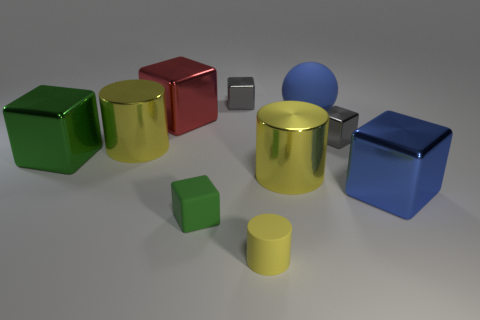Is the number of yellow matte cylinders left of the red metallic thing the same as the number of large metallic cylinders?
Offer a terse response. No. What color is the matte object that is the same shape as the red metal thing?
Your answer should be very brief. Green. How many metallic things have the same shape as the small yellow matte thing?
Offer a very short reply. 2. There is another big cube that is the same color as the matte block; what is it made of?
Your response must be concise. Metal. What number of red spheres are there?
Give a very brief answer. 0. Are there any tiny green things that have the same material as the large green cube?
Your answer should be compact. No. The shiny cube that is the same color as the rubber ball is what size?
Offer a terse response. Large. There is a red cube that is to the left of the blue shiny object; is it the same size as the green thing to the left of the rubber block?
Give a very brief answer. Yes. How big is the gray metallic thing behind the big sphere?
Offer a very short reply. Small. Is there a small rubber cube of the same color as the big rubber ball?
Keep it short and to the point. No. 